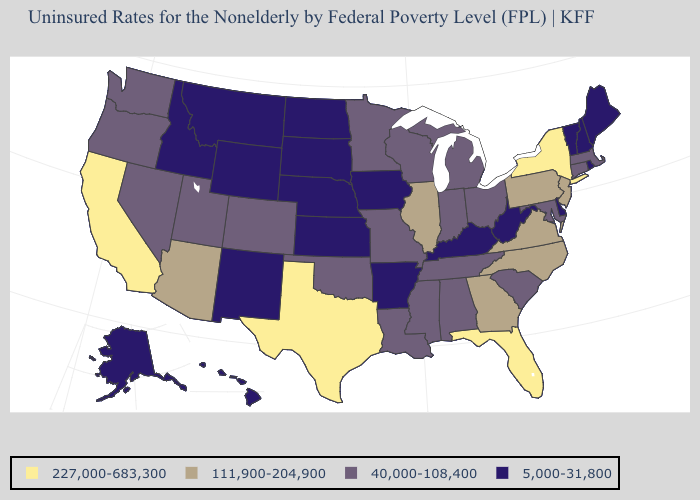What is the value of Oklahoma?
Keep it brief. 40,000-108,400. Name the states that have a value in the range 227,000-683,300?
Quick response, please. California, Florida, New York, Texas. Which states have the lowest value in the West?
Answer briefly. Alaska, Hawaii, Idaho, Montana, New Mexico, Wyoming. How many symbols are there in the legend?
Quick response, please. 4. Which states have the lowest value in the USA?
Short answer required. Alaska, Arkansas, Delaware, Hawaii, Idaho, Iowa, Kansas, Kentucky, Maine, Montana, Nebraska, New Hampshire, New Mexico, North Dakota, Rhode Island, South Dakota, Vermont, West Virginia, Wyoming. Which states hav the highest value in the MidWest?
Concise answer only. Illinois. Name the states that have a value in the range 111,900-204,900?
Quick response, please. Arizona, Georgia, Illinois, New Jersey, North Carolina, Pennsylvania, Virginia. Among the states that border Rhode Island , which have the highest value?
Write a very short answer. Connecticut, Massachusetts. Does Wyoming have a higher value than Mississippi?
Concise answer only. No. Among the states that border California , which have the lowest value?
Keep it brief. Nevada, Oregon. Name the states that have a value in the range 227,000-683,300?
Concise answer only. California, Florida, New York, Texas. Name the states that have a value in the range 5,000-31,800?
Answer briefly. Alaska, Arkansas, Delaware, Hawaii, Idaho, Iowa, Kansas, Kentucky, Maine, Montana, Nebraska, New Hampshire, New Mexico, North Dakota, Rhode Island, South Dakota, Vermont, West Virginia, Wyoming. Does Rhode Island have the lowest value in the Northeast?
Be succinct. Yes. Which states have the lowest value in the USA?
Be succinct. Alaska, Arkansas, Delaware, Hawaii, Idaho, Iowa, Kansas, Kentucky, Maine, Montana, Nebraska, New Hampshire, New Mexico, North Dakota, Rhode Island, South Dakota, Vermont, West Virginia, Wyoming. What is the value of Hawaii?
Answer briefly. 5,000-31,800. 